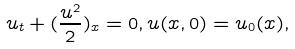<formula> <loc_0><loc_0><loc_500><loc_500>u _ { t } + ( \frac { u ^ { 2 } } { 2 } ) _ { x } = 0 , u ( x , 0 ) = u _ { 0 } ( x ) ,</formula> 